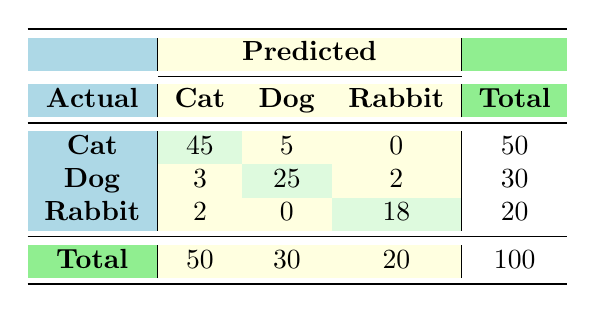What is the number of actual Cat predictions categorized as Cat? In the table, look at the row for Actual Cat and the column for Predicted Cat, which shows the value 45. This means that out of the 50 actual Cats, 45 were correctly predicted as Cats.
Answer: 45 What is the total number of predictions for Dogs? To find this, look at the total column in the Dog row. The values in the Dog row are 5 (Cat), 25 (Dog), and 2 (Rabbit). Summing these gives 5 + 25 + 2 = 32. Therefore, there were 32 predictions for Dogs.
Answer: 32 Is the number of actual Rabbits predicted as Dogs equal to the number of actual Dogs predicted as Cats? The value for actual Rabbits predicted as Dogs is found in the Rabbit row and Dog column, which is 2. The value for actual Dogs predicted as Cats is found in the Dog row and Cat column, which is 5. Since 2 is not equal to 5, the statement is false.
Answer: No What percentage of actual Cats were correctly predicted as Cats? There are 50 actual Cats, and 45 of them were correctly predicted as Cats. To find the percentage, use the formula (45/50) * 100, which equals 90%.
Answer: 90% Which animal had the highest number of correct predictions? Look at the diagonal of the confusion matrix where predictions match actual values: 45 for Cats, 25 for Dogs, and 18 for Rabbits. The highest number is 45 for Cats, which indicates they had the most correct predictions.
Answer: Cats What is the average number of correct predictions across all animal categories? Summing the correct predictions: 45 (Cat) + 25 (Dog) + 18 (Rabbit) = 88. Since there are three categories, the average correct predictions is 88 / 3, which equals approximately 29.33.
Answer: 29.33 How many total instances were misclassified as Dogs? Count the values in the Dog column excluding the correct predictions: 3 (Cat) + 2 (Rabbit) = 5. Thus, a total of 5 instances were misclassified as Dogs.
Answer: 5 Is it true that more than half of the actual Rabbits were correctly predicted? There are 20 actual Rabbits with 18 predicted correctly. Since 18 is 90% of 20, which is greater than half (10), the statement is true.
Answer: Yes 